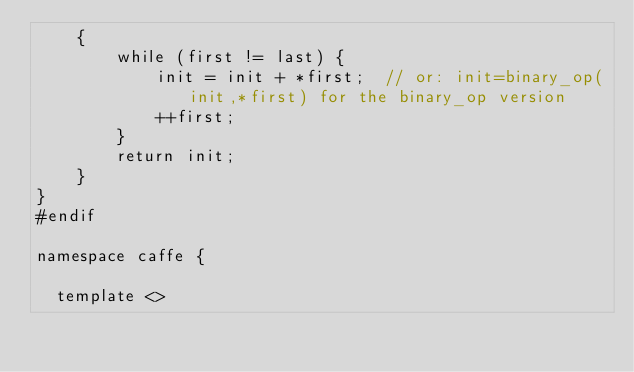<code> <loc_0><loc_0><loc_500><loc_500><_Cuda_>	{
		while (first != last) {
			init = init + *first;  // or: init=binary_op(init,*first) for the binary_op version  
			++first;
		}
		return init;
	}
}
#endif

namespace caffe {

  template <></code> 